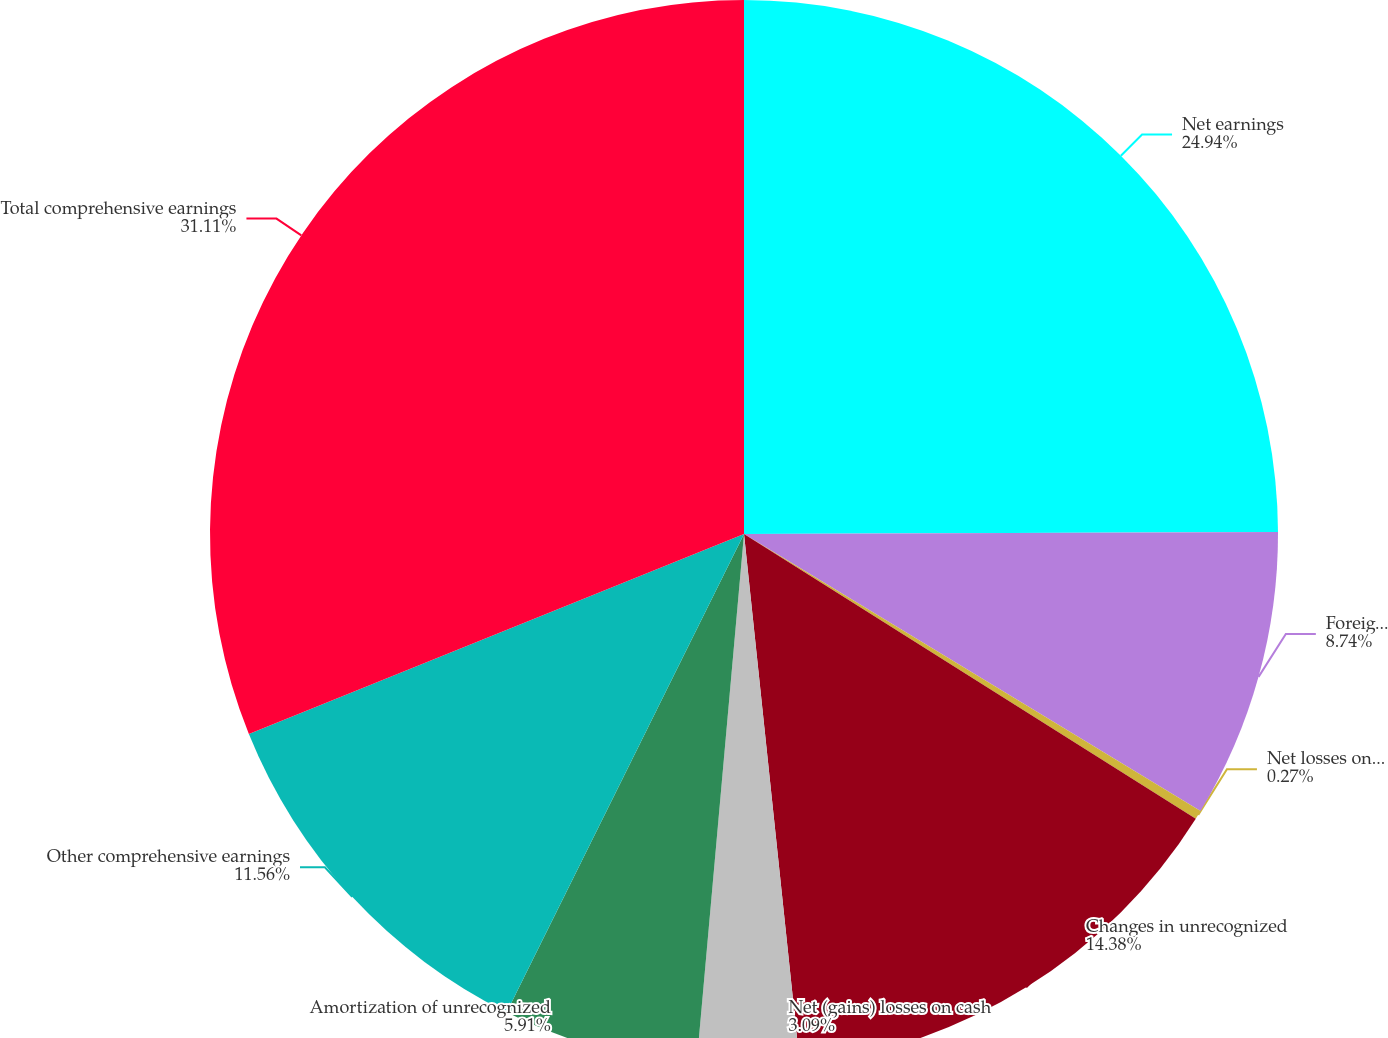<chart> <loc_0><loc_0><loc_500><loc_500><pie_chart><fcel>Net earnings<fcel>Foreign currency translation<fcel>Net losses on cash flow<fcel>Changes in unrecognized<fcel>Net (gains) losses on cash<fcel>Amortization of unrecognized<fcel>Other comprehensive earnings<fcel>Total comprehensive earnings<nl><fcel>24.94%<fcel>8.74%<fcel>0.27%<fcel>14.38%<fcel>3.09%<fcel>5.91%<fcel>11.56%<fcel>31.11%<nl></chart> 